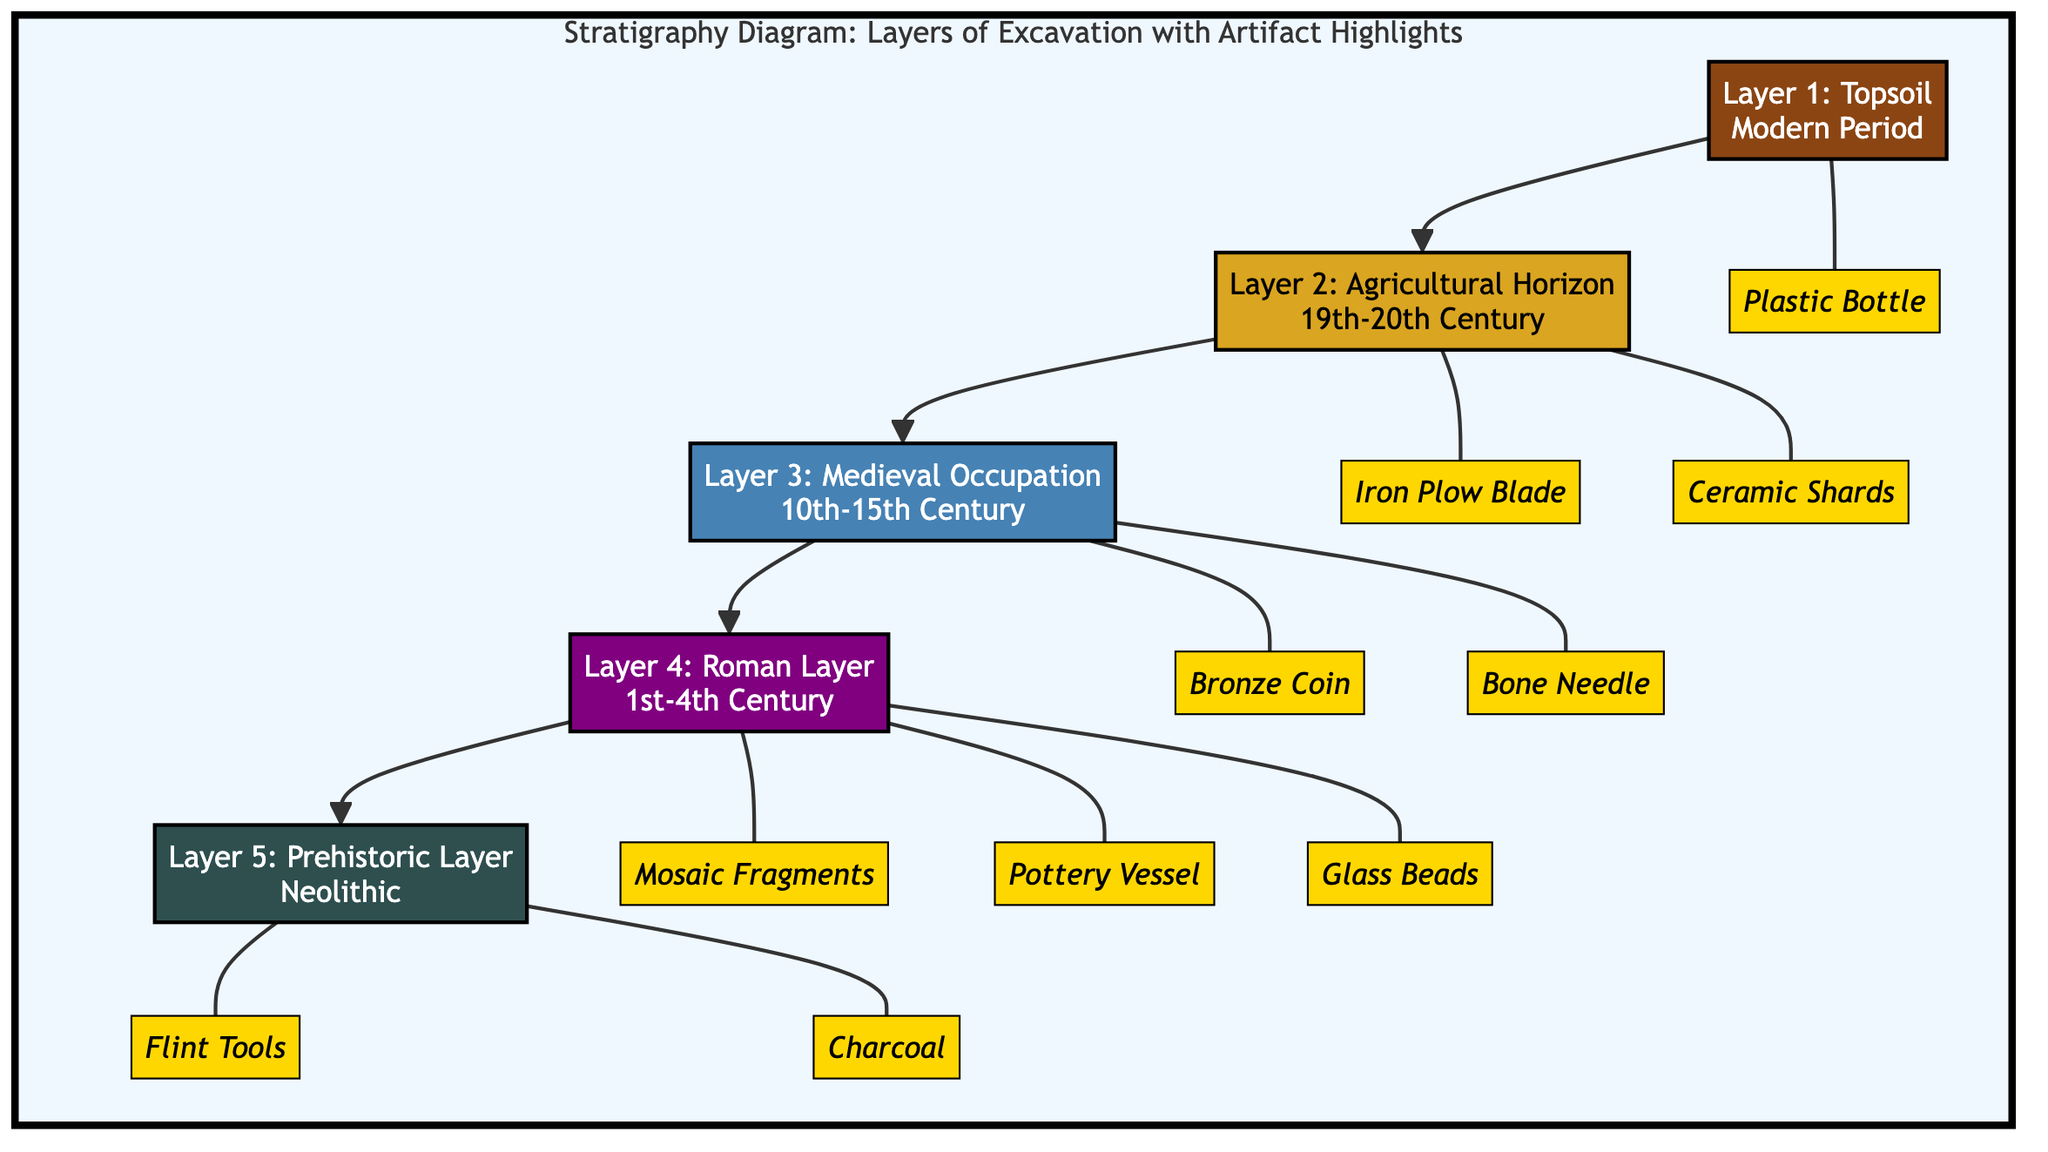What is the total number of layers in the stratigraphy diagram? The diagram displays five distinct layers of excavation, starting from the topsoil down to the prehistoric layer. Each layer is visually separated and labeled clearly.
Answer: 5 Which artifact is associated with the Medieval Occupation layer? In the diagram, the Medieval Occupation layer is linked to two artifacts: the Bronze Coin and the Bone Needle. The question asks for one associated artifact, and either answer would suffice, but only one is needed.
Answer: Bronze Coin What is the chronological order of the layers from top to bottom? To determine the order, we start from Layer 1 at the top, which is the Topsoil, followed by Layer 2 (Agricultural Horizon), Layer 3 (Medieval Occupation), Layer 4 (Roman Layer), and finally Layer 5 (Prehistoric Layer) at the bottom.
Answer: Topsoil, Agricultural Horizon, Medieval Occupation, Roman Layer, Prehistoric Layer How many artifacts are found in the Roman Layer? The Roman Layer is associated with three artifacts: Mosaic Fragments, Pottery Vessel, and Glass Beads. Thus, by counting the artifacts linked to this layer, we find the total.
Answer: 3 Which layer contains the Flint Tools artifact? The Flint Tools artifact is associated with the Prehistoric Layer, as indicated by its connection in the diagram. This layer is placed at the bottom of the stratigraphy.
Answer: Prehistoric Layer What is the color code used for the Agricultural Horizon layer? The Agricultural Horizon layer is represented with a specific color code, which in this case is a shade of gold (DAA520). This is distinctly shown in the diagram next to the label for that layer.
Answer: #DAA520 How many artifacts are linked to the Agricultural Horizon layer? This layer includes two artifacts: the Iron Plow Blade and the Ceramic Shards. Counting the artifacts connected to this layer, we can determine the total.
Answer: 2 What is the time period of the Medieval Occupation layer? The timeframe specified for the Medieval Occupation layer is the 10th to 15th Century. This information is clearly indicated alongside the layer's label in the diagram.
Answer: 10th-15th Century Which type of artifact is highlighted in the Topsoil layer? The diagram shows that the Topsoil layer is linked to a Plastic Bottle. Thus, for any inquiry regarding this layer, the answer corresponds directly to the depicted artifact.
Answer: Plastic Bottle 